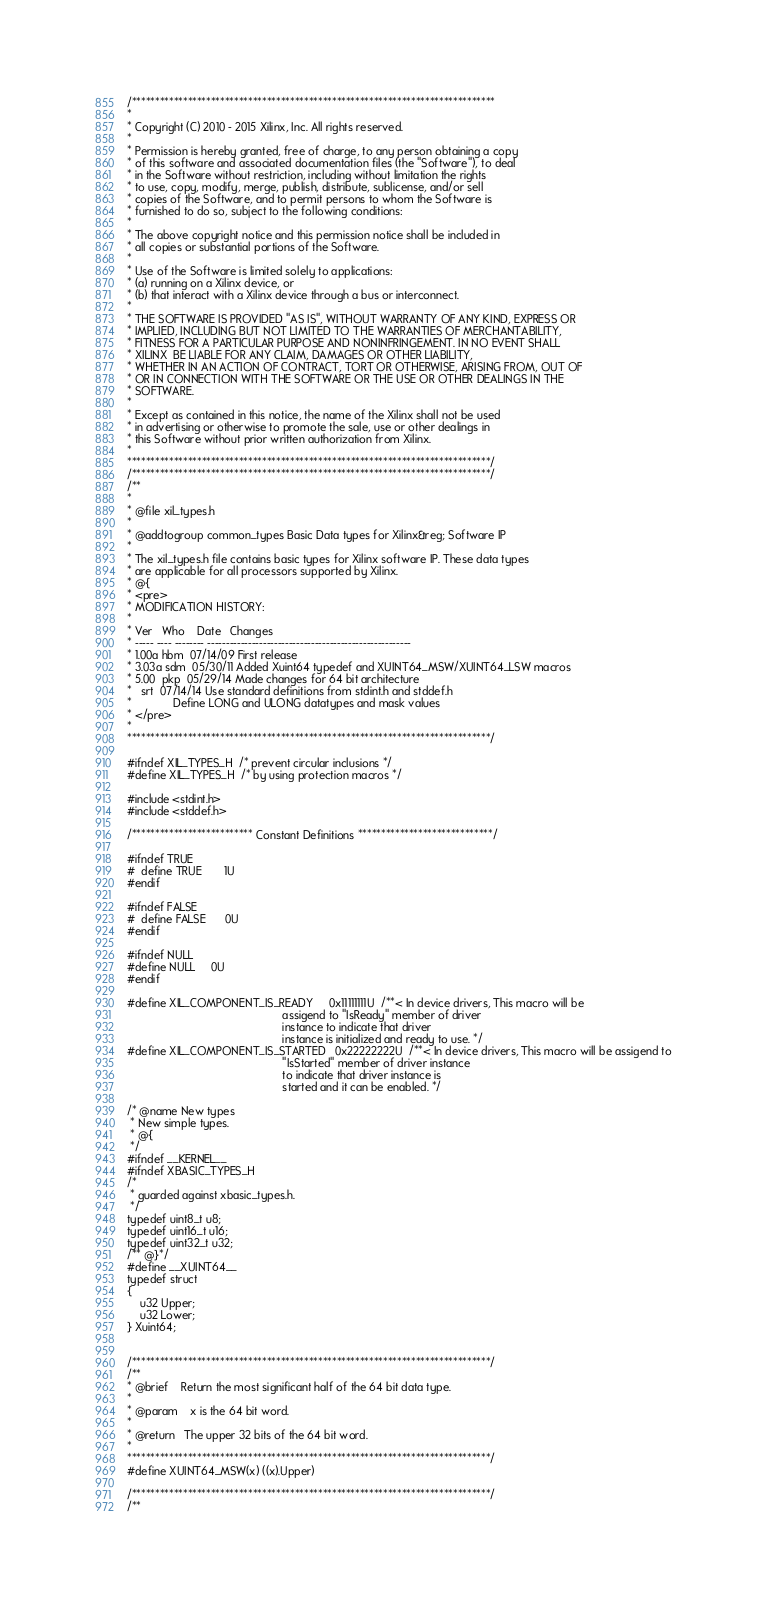Convert code to text. <code><loc_0><loc_0><loc_500><loc_500><_C_>/******************************************************************************
*
* Copyright (C) 2010 - 2015 Xilinx, Inc. All rights reserved.
*
* Permission is hereby granted, free of charge, to any person obtaining a copy
* of this software and associated documentation files (the "Software"), to deal
* in the Software without restriction, including without limitation the rights
* to use, copy, modify, merge, publish, distribute, sublicense, and/or sell
* copies of the Software, and to permit persons to whom the Software is
* furnished to do so, subject to the following conditions:
*
* The above copyright notice and this permission notice shall be included in
* all copies or substantial portions of the Software.
*
* Use of the Software is limited solely to applications:
* (a) running on a Xilinx device, or
* (b) that interact with a Xilinx device through a bus or interconnect.
*
* THE SOFTWARE IS PROVIDED "AS IS", WITHOUT WARRANTY OF ANY KIND, EXPRESS OR
* IMPLIED, INCLUDING BUT NOT LIMITED TO THE WARRANTIES OF MERCHANTABILITY,
* FITNESS FOR A PARTICULAR PURPOSE AND NONINFRINGEMENT. IN NO EVENT SHALL
* XILINX  BE LIABLE FOR ANY CLAIM, DAMAGES OR OTHER LIABILITY,
* WHETHER IN AN ACTION OF CONTRACT, TORT OR OTHERWISE, ARISING FROM, OUT OF
* OR IN CONNECTION WITH THE SOFTWARE OR THE USE OR OTHER DEALINGS IN THE
* SOFTWARE.
*
* Except as contained in this notice, the name of the Xilinx shall not be used
* in advertising or otherwise to promote the sale, use or other dealings in
* this Software without prior written authorization from Xilinx.
*
******************************************************************************/
/*****************************************************************************/
/**
*
* @file xil_types.h
*
* @addtogroup common_types Basic Data types for Xilinx&reg; Software IP
*
* The xil_types.h file contains basic types for Xilinx software IP. These data types
* are applicable for all processors supported by Xilinx.
* @{
* <pre>
* MODIFICATION HISTORY:
*
* Ver   Who    Date   Changes
* ----- ---- -------- -------------------------------------------------------
* 1.00a hbm  07/14/09 First release
* 3.03a sdm  05/30/11 Added Xuint64 typedef and XUINT64_MSW/XUINT64_LSW macros
* 5.00 	pkp  05/29/14 Made changes for 64 bit architecture
*	srt  07/14/14 Use standard definitions from stdint.h and stddef.h
*		      Define LONG and ULONG datatypes and mask values
* </pre>
*
******************************************************************************/

#ifndef XIL_TYPES_H	/* prevent circular inclusions */
#define XIL_TYPES_H	/* by using protection macros */

#include <stdint.h>
#include <stddef.h>

/************************** Constant Definitions *****************************/

#ifndef TRUE
#  define TRUE		1U
#endif

#ifndef FALSE
#  define FALSE		0U
#endif

#ifndef NULL
#define NULL		0U
#endif

#define XIL_COMPONENT_IS_READY     0x11111111U  /**< In device drivers, This macro will be
                                                 assigend to "IsReady" member of driver
												 instance to indicate that driver
												 instance is initialized and ready to use. */
#define XIL_COMPONENT_IS_STARTED   0x22222222U  /**< In device drivers, This macro will be assigend to
                                                 "IsStarted" member of driver instance
												 to indicate that driver instance is
												 started and it can be enabled. */

/* @name New types
 * New simple types.
 * @{
 */
#ifndef __KERNEL__
#ifndef XBASIC_TYPES_H
/*
 * guarded against xbasic_types.h.
 */
typedef uint8_t u8;
typedef uint16_t u16;
typedef uint32_t u32;
/** @}*/
#define __XUINT64__
typedef struct
{
	u32 Upper;
	u32 Lower;
} Xuint64;


/*****************************************************************************/
/**
* @brief    Return the most significant half of the 64 bit data type.
*
* @param    x is the 64 bit word.
*
* @return   The upper 32 bits of the 64 bit word.
*
******************************************************************************/
#define XUINT64_MSW(x) ((x).Upper)

/*****************************************************************************/
/**</code> 